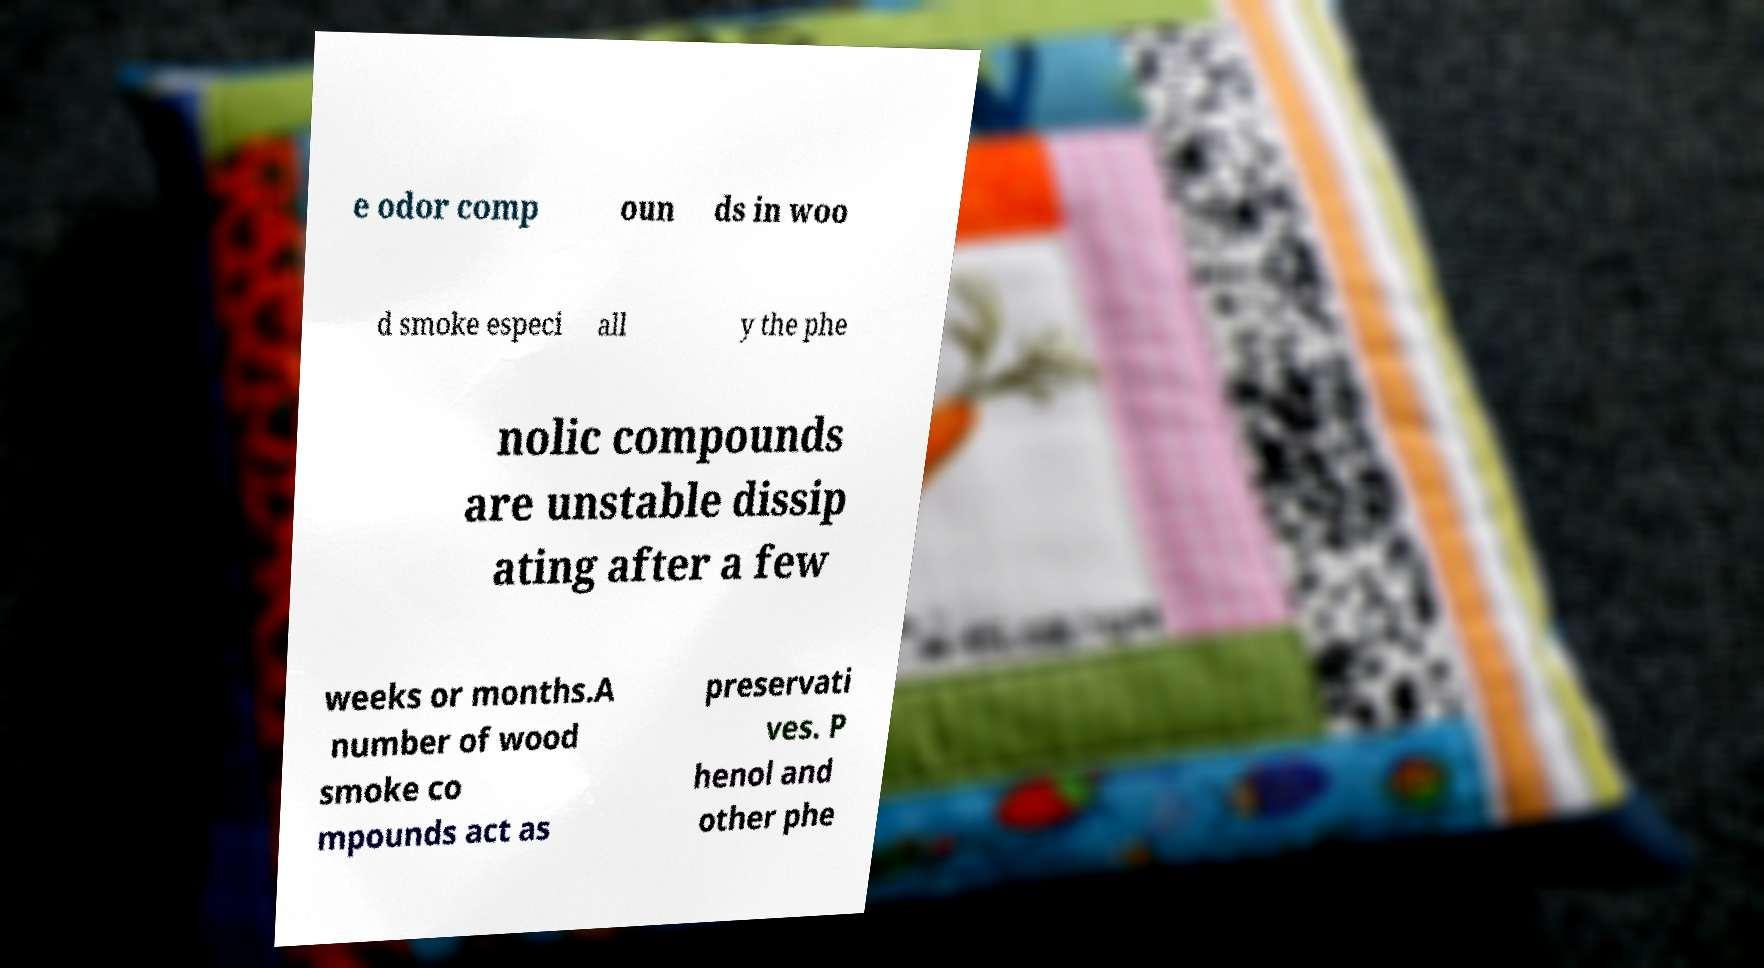Can you read and provide the text displayed in the image?This photo seems to have some interesting text. Can you extract and type it out for me? e odor comp oun ds in woo d smoke especi all y the phe nolic compounds are unstable dissip ating after a few weeks or months.A number of wood smoke co mpounds act as preservati ves. P henol and other phe 